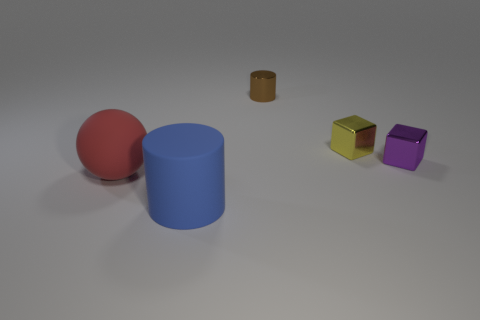Are there any green metal blocks of the same size as the blue cylinder?
Make the answer very short. No. There is a cylinder that is to the right of the big blue matte cylinder; how big is it?
Your answer should be compact. Small. The thing in front of the matte thing left of the large object that is in front of the big red ball is what color?
Your response must be concise. Blue. What is the color of the large thing left of the cylinder that is in front of the purple metallic cube?
Offer a very short reply. Red. Are there more big red objects that are in front of the small brown object than purple blocks that are to the left of the large blue cylinder?
Your answer should be compact. Yes. Are the large object that is in front of the sphere and the large thing that is behind the big blue matte cylinder made of the same material?
Provide a succinct answer. Yes. Are there any purple shiny cubes to the right of the red rubber sphere?
Make the answer very short. Yes. How many yellow objects are large cylinders or tiny shiny cylinders?
Ensure brevity in your answer.  0. Does the small yellow cube have the same material as the large thing behind the blue thing?
Offer a terse response. No. The other shiny thing that is the same shape as the blue thing is what size?
Provide a short and direct response. Small. 